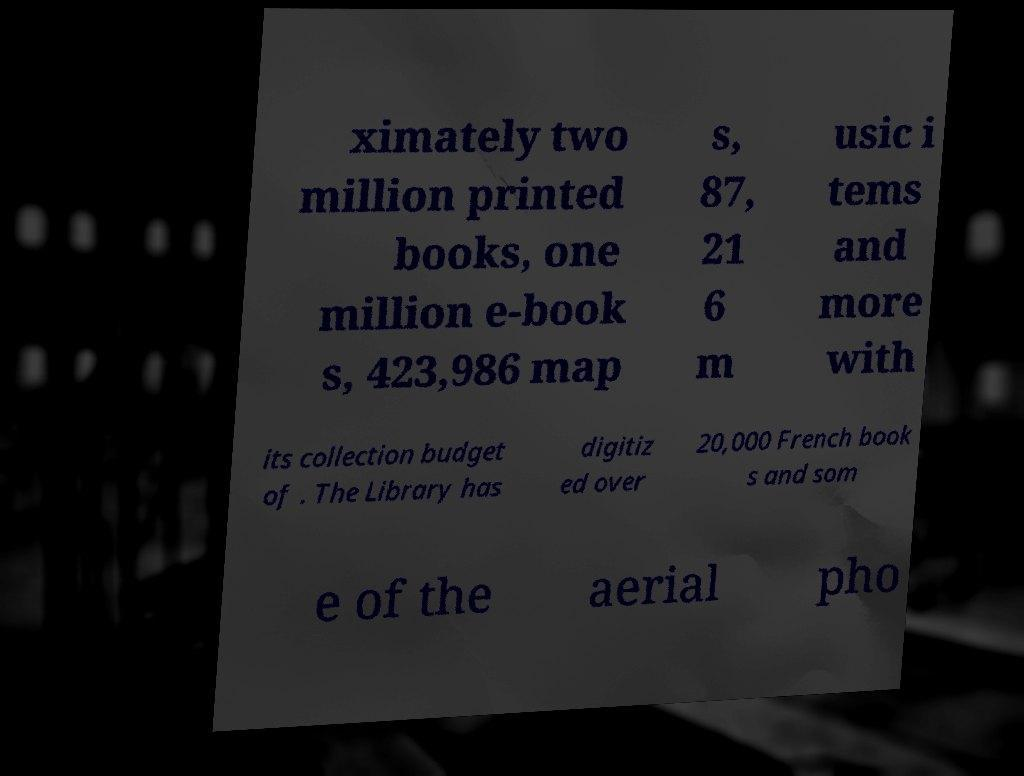Please identify and transcribe the text found in this image. ximately two million printed books, one million e-book s, 423,986 map s, 87, 21 6 m usic i tems and more with its collection budget of . The Library has digitiz ed over 20,000 French book s and som e of the aerial pho 